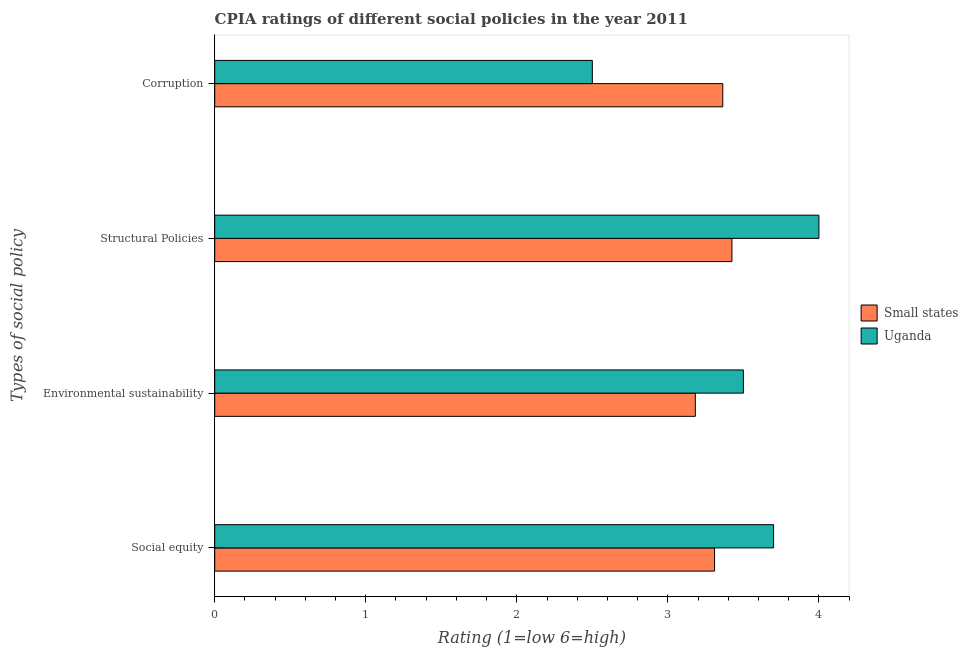How many different coloured bars are there?
Offer a very short reply. 2. How many bars are there on the 2nd tick from the top?
Keep it short and to the point. 2. What is the label of the 4th group of bars from the top?
Give a very brief answer. Social equity. Across all countries, what is the maximum cpia rating of corruption?
Your answer should be compact. 3.36. Across all countries, what is the minimum cpia rating of structural policies?
Ensure brevity in your answer.  3.42. In which country was the cpia rating of structural policies maximum?
Offer a very short reply. Uganda. In which country was the cpia rating of corruption minimum?
Your answer should be very brief. Uganda. What is the total cpia rating of corruption in the graph?
Offer a very short reply. 5.86. What is the difference between the cpia rating of structural policies in Small states and that in Uganda?
Ensure brevity in your answer.  -0.58. What is the difference between the cpia rating of social equity in Small states and the cpia rating of corruption in Uganda?
Your answer should be compact. 0.81. What is the average cpia rating of corruption per country?
Provide a succinct answer. 2.93. What is the difference between the cpia rating of structural policies and cpia rating of corruption in Uganda?
Make the answer very short. 1.5. In how many countries, is the cpia rating of structural policies greater than 2 ?
Your answer should be compact. 2. What is the ratio of the cpia rating of environmental sustainability in Small states to that in Uganda?
Offer a terse response. 0.91. Is the difference between the cpia rating of structural policies in Small states and Uganda greater than the difference between the cpia rating of social equity in Small states and Uganda?
Make the answer very short. No. What is the difference between the highest and the second highest cpia rating of environmental sustainability?
Your answer should be compact. 0.32. What is the difference between the highest and the lowest cpia rating of corruption?
Make the answer very short. 0.86. Is the sum of the cpia rating of environmental sustainability in Small states and Uganda greater than the maximum cpia rating of structural policies across all countries?
Make the answer very short. Yes. What does the 1st bar from the top in Environmental sustainability represents?
Ensure brevity in your answer.  Uganda. What does the 2nd bar from the bottom in Corruption represents?
Your response must be concise. Uganda. Is it the case that in every country, the sum of the cpia rating of social equity and cpia rating of environmental sustainability is greater than the cpia rating of structural policies?
Offer a very short reply. Yes. How many bars are there?
Offer a terse response. 8. Are all the bars in the graph horizontal?
Offer a terse response. Yes. How many countries are there in the graph?
Give a very brief answer. 2. How many legend labels are there?
Keep it short and to the point. 2. What is the title of the graph?
Your answer should be compact. CPIA ratings of different social policies in the year 2011. Does "Morocco" appear as one of the legend labels in the graph?
Offer a terse response. No. What is the label or title of the X-axis?
Your answer should be very brief. Rating (1=low 6=high). What is the label or title of the Y-axis?
Your answer should be very brief. Types of social policy. What is the Rating (1=low 6=high) of Small states in Social equity?
Make the answer very short. 3.31. What is the Rating (1=low 6=high) in Small states in Environmental sustainability?
Give a very brief answer. 3.18. What is the Rating (1=low 6=high) of Small states in Structural Policies?
Your answer should be compact. 3.42. What is the Rating (1=low 6=high) in Uganda in Structural Policies?
Give a very brief answer. 4. What is the Rating (1=low 6=high) in Small states in Corruption?
Offer a very short reply. 3.36. What is the Rating (1=low 6=high) in Uganda in Corruption?
Provide a short and direct response. 2.5. Across all Types of social policy, what is the maximum Rating (1=low 6=high) of Small states?
Your response must be concise. 3.42. Across all Types of social policy, what is the maximum Rating (1=low 6=high) of Uganda?
Offer a very short reply. 4. Across all Types of social policy, what is the minimum Rating (1=low 6=high) of Small states?
Your answer should be very brief. 3.18. What is the total Rating (1=low 6=high) in Small states in the graph?
Offer a very short reply. 13.28. What is the total Rating (1=low 6=high) in Uganda in the graph?
Make the answer very short. 13.7. What is the difference between the Rating (1=low 6=high) of Small states in Social equity and that in Environmental sustainability?
Your answer should be very brief. 0.13. What is the difference between the Rating (1=low 6=high) in Uganda in Social equity and that in Environmental sustainability?
Your answer should be compact. 0.2. What is the difference between the Rating (1=low 6=high) of Small states in Social equity and that in Structural Policies?
Provide a short and direct response. -0.12. What is the difference between the Rating (1=low 6=high) in Uganda in Social equity and that in Structural Policies?
Your answer should be compact. -0.3. What is the difference between the Rating (1=low 6=high) in Small states in Social equity and that in Corruption?
Your answer should be very brief. -0.05. What is the difference between the Rating (1=low 6=high) of Small states in Environmental sustainability and that in Structural Policies?
Your answer should be very brief. -0.24. What is the difference between the Rating (1=low 6=high) in Small states in Environmental sustainability and that in Corruption?
Ensure brevity in your answer.  -0.18. What is the difference between the Rating (1=low 6=high) of Uganda in Environmental sustainability and that in Corruption?
Provide a succinct answer. 1. What is the difference between the Rating (1=low 6=high) in Small states in Structural Policies and that in Corruption?
Offer a terse response. 0.06. What is the difference between the Rating (1=low 6=high) in Uganda in Structural Policies and that in Corruption?
Give a very brief answer. 1.5. What is the difference between the Rating (1=low 6=high) of Small states in Social equity and the Rating (1=low 6=high) of Uganda in Environmental sustainability?
Give a very brief answer. -0.19. What is the difference between the Rating (1=low 6=high) in Small states in Social equity and the Rating (1=low 6=high) in Uganda in Structural Policies?
Your answer should be very brief. -0.69. What is the difference between the Rating (1=low 6=high) in Small states in Social equity and the Rating (1=low 6=high) in Uganda in Corruption?
Provide a succinct answer. 0.81. What is the difference between the Rating (1=low 6=high) of Small states in Environmental sustainability and the Rating (1=low 6=high) of Uganda in Structural Policies?
Ensure brevity in your answer.  -0.82. What is the difference between the Rating (1=low 6=high) of Small states in Environmental sustainability and the Rating (1=low 6=high) of Uganda in Corruption?
Ensure brevity in your answer.  0.68. What is the difference between the Rating (1=low 6=high) of Small states in Structural Policies and the Rating (1=low 6=high) of Uganda in Corruption?
Your answer should be very brief. 0.92. What is the average Rating (1=low 6=high) in Small states per Types of social policy?
Offer a terse response. 3.32. What is the average Rating (1=low 6=high) of Uganda per Types of social policy?
Offer a very short reply. 3.42. What is the difference between the Rating (1=low 6=high) of Small states and Rating (1=low 6=high) of Uganda in Social equity?
Give a very brief answer. -0.39. What is the difference between the Rating (1=low 6=high) of Small states and Rating (1=low 6=high) of Uganda in Environmental sustainability?
Offer a very short reply. -0.32. What is the difference between the Rating (1=low 6=high) of Small states and Rating (1=low 6=high) of Uganda in Structural Policies?
Ensure brevity in your answer.  -0.58. What is the difference between the Rating (1=low 6=high) in Small states and Rating (1=low 6=high) in Uganda in Corruption?
Offer a terse response. 0.86. What is the ratio of the Rating (1=low 6=high) in Uganda in Social equity to that in Environmental sustainability?
Keep it short and to the point. 1.06. What is the ratio of the Rating (1=low 6=high) of Small states in Social equity to that in Structural Policies?
Offer a very short reply. 0.97. What is the ratio of the Rating (1=low 6=high) in Uganda in Social equity to that in Structural Policies?
Give a very brief answer. 0.93. What is the ratio of the Rating (1=low 6=high) in Small states in Social equity to that in Corruption?
Ensure brevity in your answer.  0.98. What is the ratio of the Rating (1=low 6=high) in Uganda in Social equity to that in Corruption?
Make the answer very short. 1.48. What is the ratio of the Rating (1=low 6=high) of Small states in Environmental sustainability to that in Structural Policies?
Give a very brief answer. 0.93. What is the ratio of the Rating (1=low 6=high) in Small states in Environmental sustainability to that in Corruption?
Your answer should be compact. 0.95. What is the ratio of the Rating (1=low 6=high) of Small states in Structural Policies to that in Corruption?
Provide a short and direct response. 1.02. What is the ratio of the Rating (1=low 6=high) in Uganda in Structural Policies to that in Corruption?
Give a very brief answer. 1.6. What is the difference between the highest and the second highest Rating (1=low 6=high) of Small states?
Offer a very short reply. 0.06. What is the difference between the highest and the lowest Rating (1=low 6=high) of Small states?
Your answer should be compact. 0.24. What is the difference between the highest and the lowest Rating (1=low 6=high) in Uganda?
Ensure brevity in your answer.  1.5. 